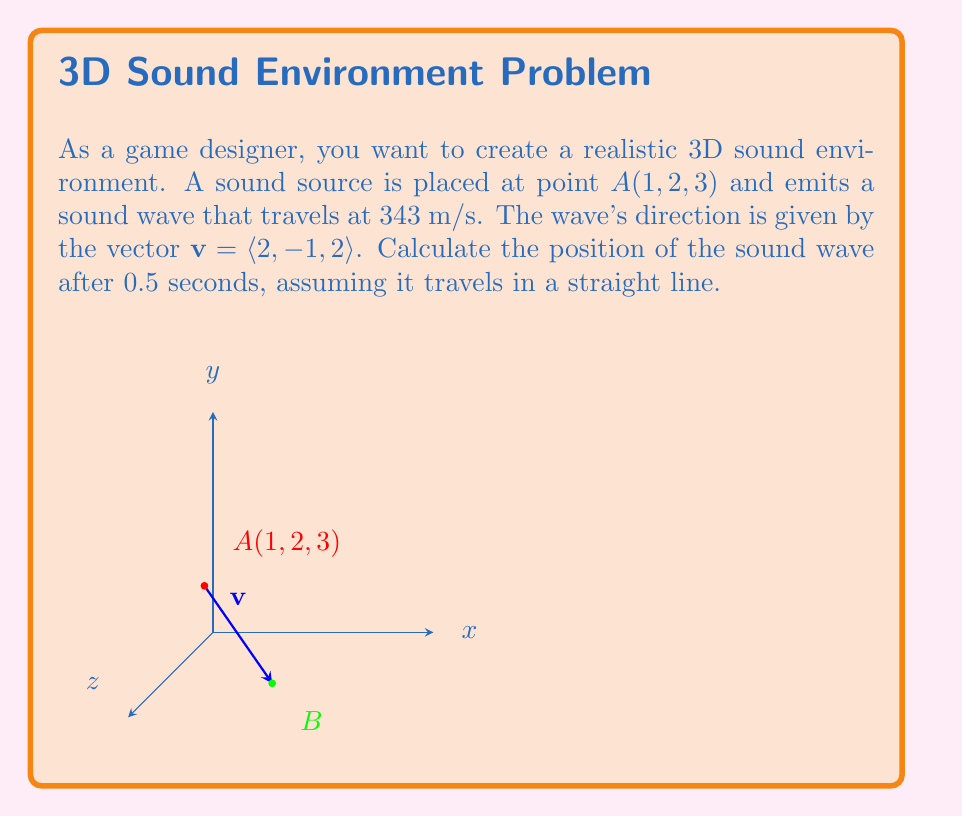Provide a solution to this math problem. Let's approach this step-by-step:

1) We're given the initial position $A(1, 2, 3)$ and the direction vector $\mathbf{v} = \langle 2, -1, 2 \rangle$.

2) The sound wave travels at 343 m/s for 0.5 seconds. Let's calculate the distance:
   $$d = 343 \text{ m/s} \times 0.5 \text{ s} = 171.5 \text{ m}$$

3) We need to normalize the direction vector to get a unit vector:
   $$\|\mathbf{v}\| = \sqrt{2^2 + (-1)^2 + 2^2} = \sqrt{9} = 3$$
   $$\hat{\mathbf{v}} = \frac{\mathbf{v}}{\|\mathbf{v}\|} = \left\langle \frac{2}{3}, -\frac{1}{3}, \frac{2}{3} \right\rangle$$

4) Now, we can calculate the displacement vector by multiplying the unit vector by the distance:
   $$\mathbf{d} = 171.5 \times \hat{\mathbf{v}} = \left\langle 171.5 \times \frac{2}{3}, 171.5 \times (-\frac{1}{3}), 171.5 \times \frac{2}{3} \right\rangle$$
   $$\mathbf{d} = \langle 114.33, -57.17, 114.33 \rangle$$

5) Finally, we add this displacement to the initial position:
   $$B = A + \mathbf{d} = (1, 2, 3) + (114.33, -57.17, 114.33)$$
   $$B = (115.33, -55.17, 117.33)$$

Therefore, after 0.5 seconds, the sound wave will be at position (115.33, -55.17, 117.33).
Answer: (115.33, -55.17, 117.33) 